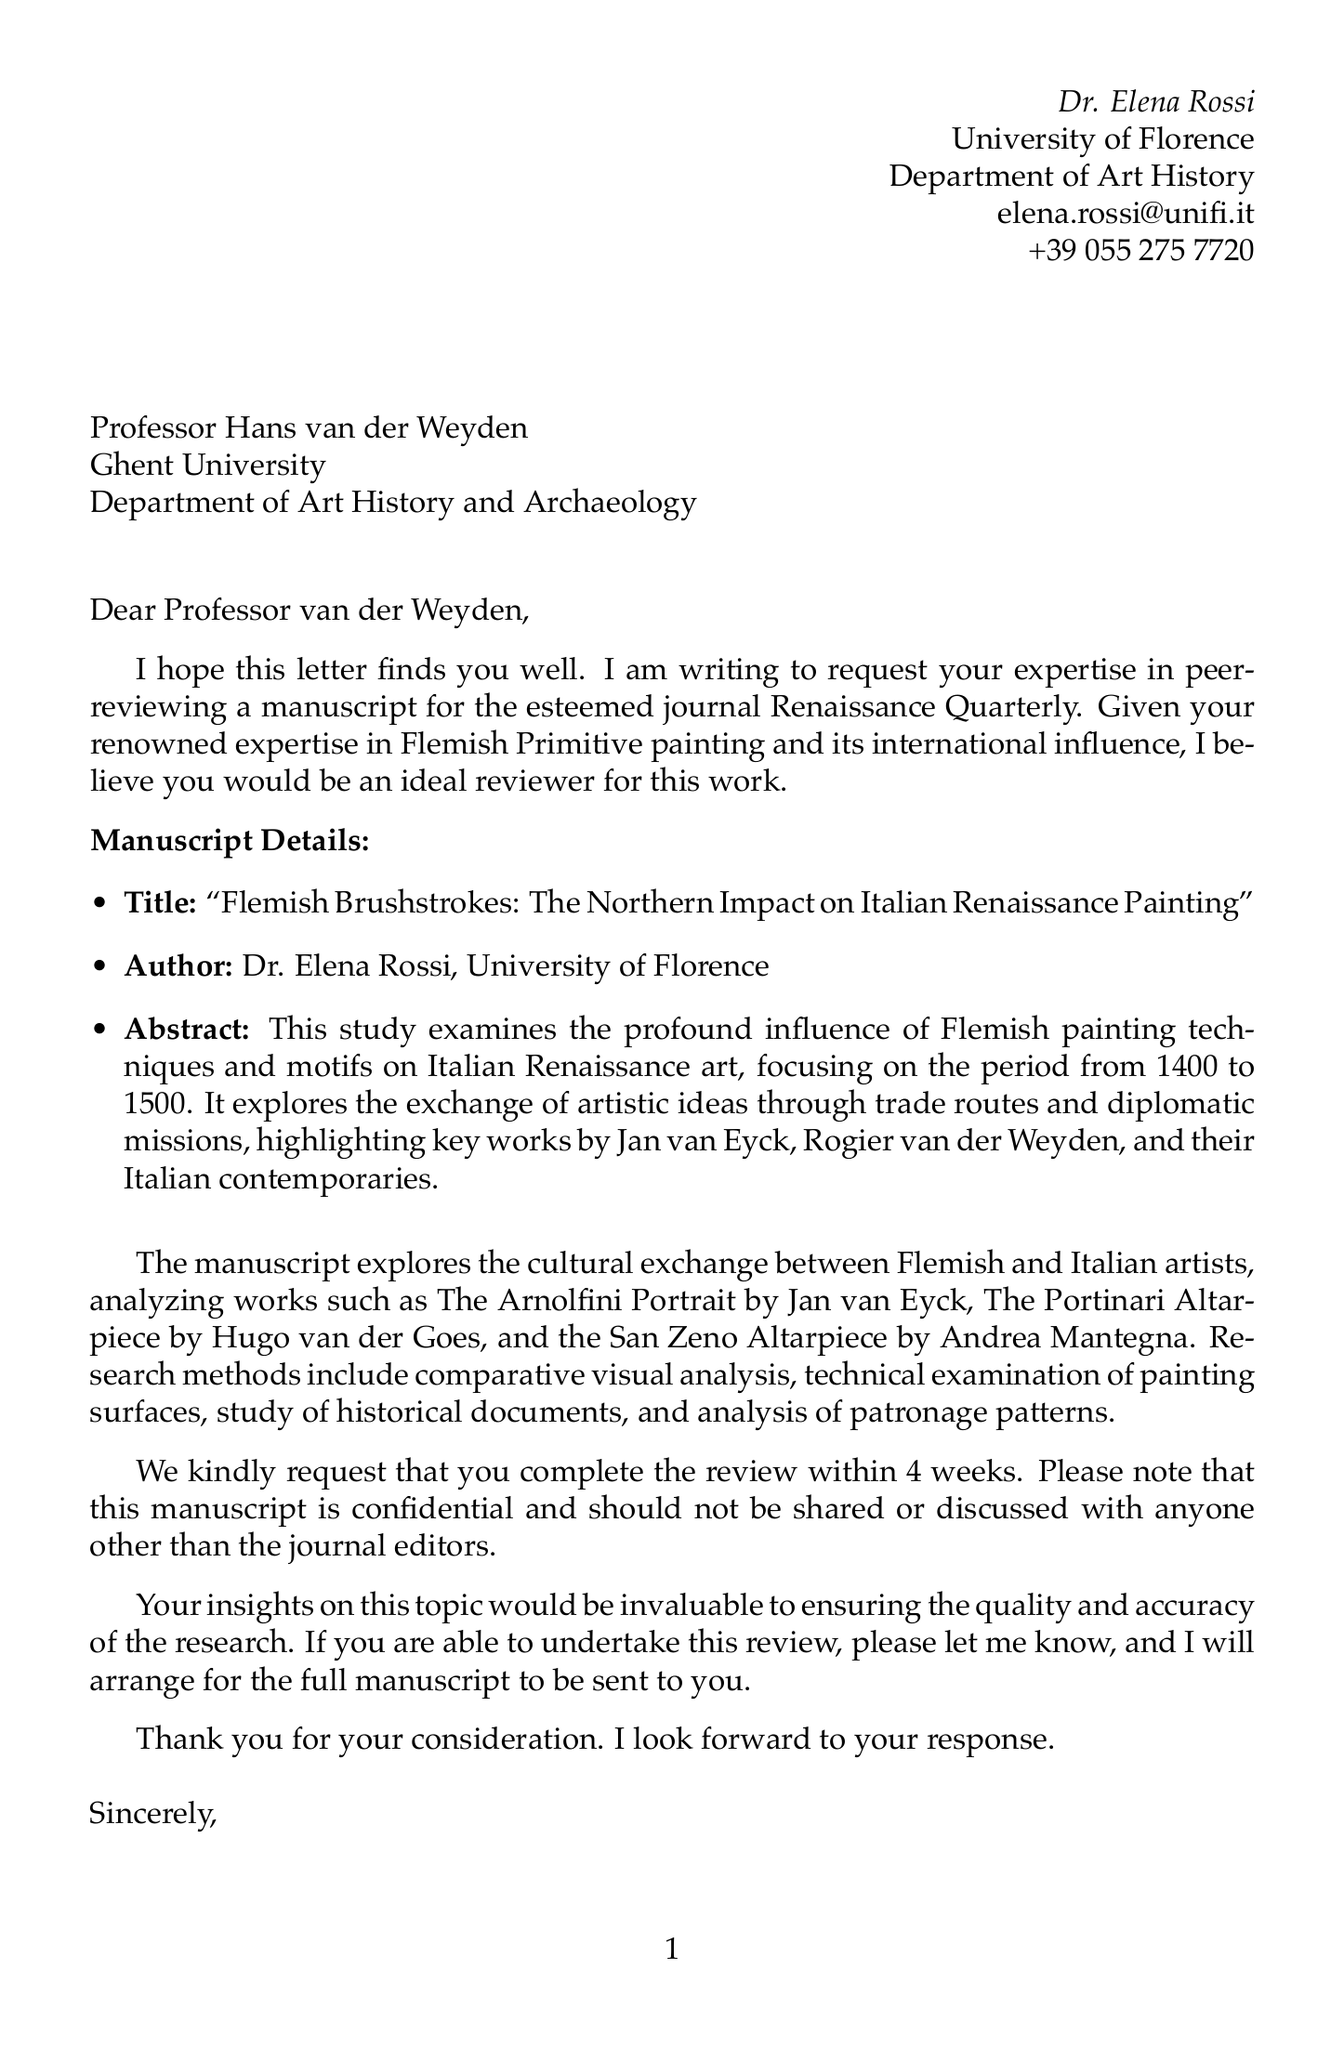What is the title of the manuscript? The title of the manuscript is specified in the document under manuscript details.
Answer: Flemish Brushstrokes: The Northern Impact on Italian Renaissance Painting Who is the author of the manuscript? The author of the manuscript is mentioned at the beginning of the letter.
Answer: Dr. Elena Rossi What is the primary focus period of the study? The primary focus period of the study is stated in the abstract of the manuscript.
Answer: 1400 to 1500 How many key artists are listed in the document? The number of key artists can be determined by counting the entries in the keyArtists section.
Answer: Six What is the expected review completion time? The expected review completion time is stated explicitly in the request for peer review.
Answer: 4 weeks What techniques are emphasized in the manuscript's research methods? The research methods listed in the document contain various techniques used for analysis.
Answer: Comparative visual analysis What confidentiality statement is included in the letter? The confidentiality statement indicates how the manuscript should be handled.
Answer: This manuscript is confidential and should not be shared or discussed with anyone other than the journal editors What was the title of a relevant exhibition mentioned? A title of a relevant exhibition is provided in the relevant exhibitions section.
Answer: Flemish Masters and Renaissance Italy: Dialogue between Traditions, Uffizi Gallery, Florence, 2018 What is the name of the journal for which the manuscript is being reviewed? The name of the journal that is hosting the manuscript review is clearly provided in the document.
Answer: Renaissance Quarterly 